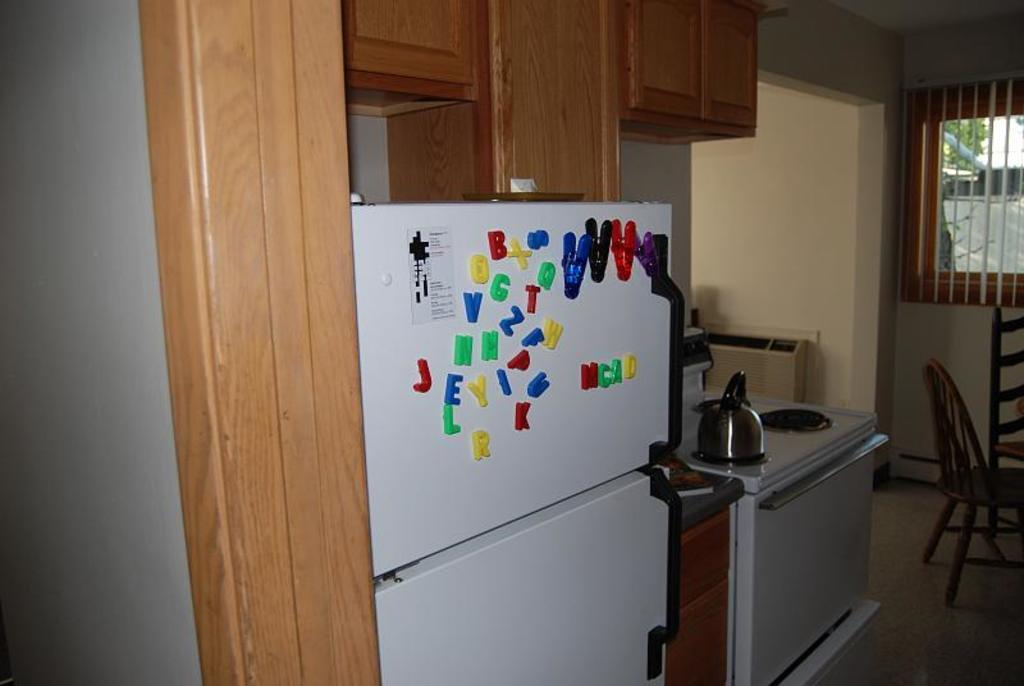<image>
Relay a brief, clear account of the picture shown. MCAD displayed on a frigerator in magnets of different colors 